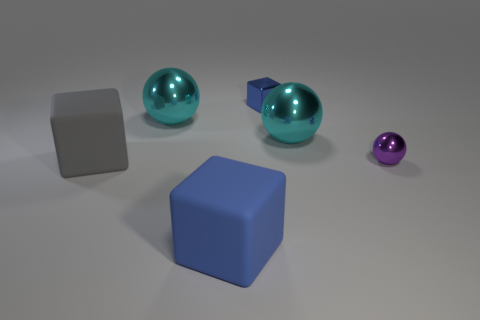Add 2 small purple metal balls. How many objects exist? 8 Add 1 small blue objects. How many small blue objects are left? 2 Add 5 blue matte things. How many blue matte things exist? 6 Subtract 0 red balls. How many objects are left? 6 Subtract all big rubber blocks. Subtract all large cyan shiny things. How many objects are left? 2 